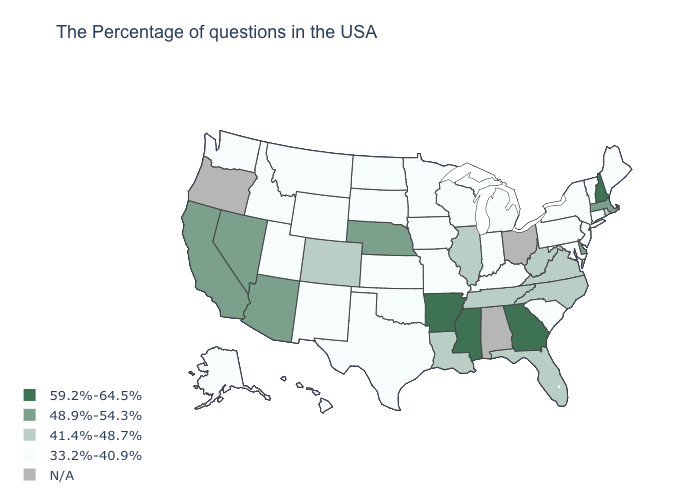What is the value of Oklahoma?
Give a very brief answer. 33.2%-40.9%. Name the states that have a value in the range 41.4%-48.7%?
Keep it brief. Rhode Island, Virginia, North Carolina, West Virginia, Florida, Tennessee, Illinois, Louisiana, Colorado. How many symbols are there in the legend?
Keep it brief. 5. What is the highest value in the West ?
Be succinct. 48.9%-54.3%. Which states hav the highest value in the Northeast?
Write a very short answer. New Hampshire. What is the value of Missouri?
Write a very short answer. 33.2%-40.9%. What is the value of Arizona?
Short answer required. 48.9%-54.3%. What is the value of Hawaii?
Answer briefly. 33.2%-40.9%. Name the states that have a value in the range 33.2%-40.9%?
Give a very brief answer. Maine, Vermont, Connecticut, New York, New Jersey, Maryland, Pennsylvania, South Carolina, Michigan, Kentucky, Indiana, Wisconsin, Missouri, Minnesota, Iowa, Kansas, Oklahoma, Texas, South Dakota, North Dakota, Wyoming, New Mexico, Utah, Montana, Idaho, Washington, Alaska, Hawaii. Among the states that border Nevada , does California have the lowest value?
Keep it brief. No. Does Georgia have the highest value in the USA?
Give a very brief answer. Yes. Which states have the highest value in the USA?
Keep it brief. New Hampshire, Georgia, Mississippi, Arkansas. What is the value of Nevada?
Write a very short answer. 48.9%-54.3%. What is the lowest value in the USA?
Answer briefly. 33.2%-40.9%. 